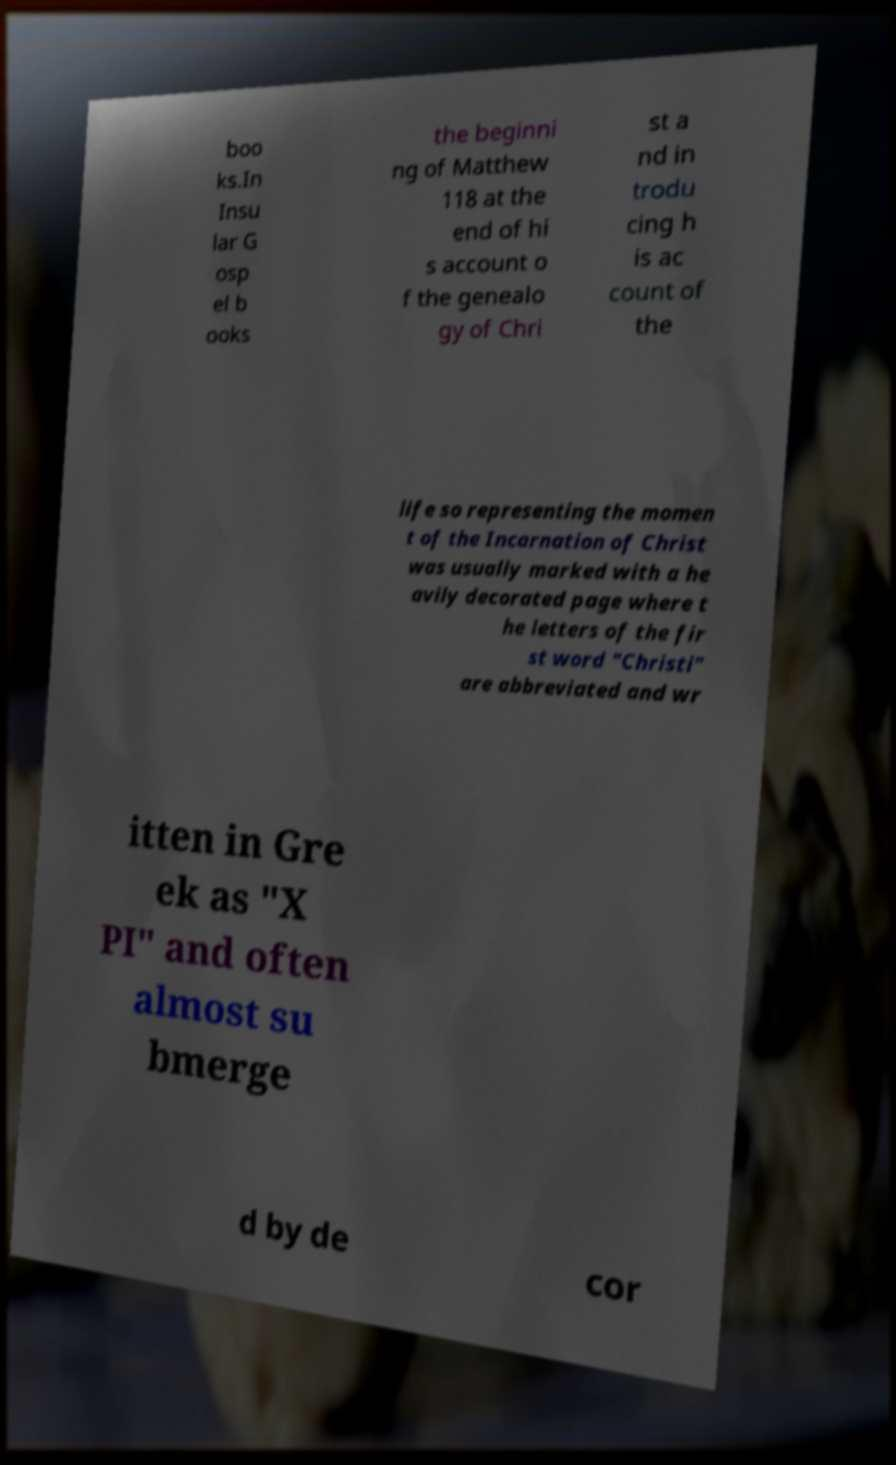Can you accurately transcribe the text from the provided image for me? boo ks.In Insu lar G osp el b ooks the beginni ng of Matthew 118 at the end of hi s account o f the genealo gy of Chri st a nd in trodu cing h is ac count of the life so representing the momen t of the Incarnation of Christ was usually marked with a he avily decorated page where t he letters of the fir st word "Christi" are abbreviated and wr itten in Gre ek as "X PI" and often almost su bmerge d by de cor 